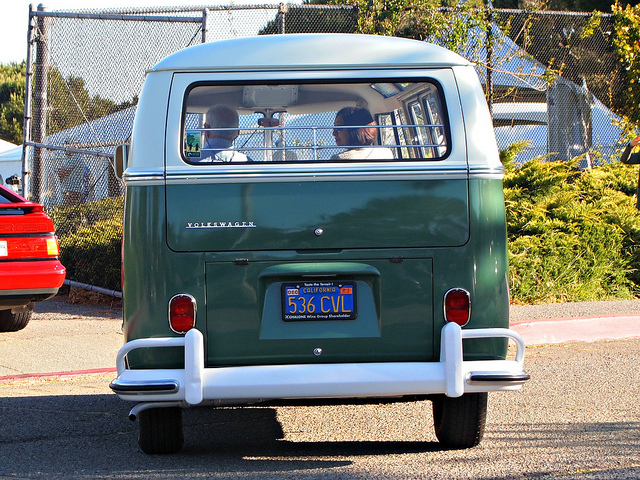Please identify all text content in this image. 536 CVL VOLKSWAGIN 